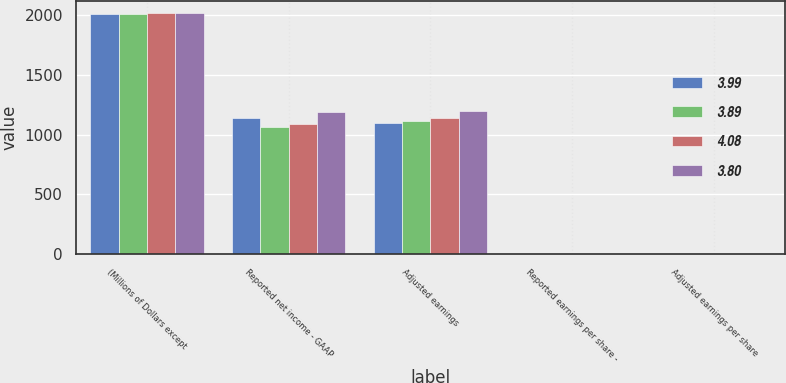Convert chart. <chart><loc_0><loc_0><loc_500><loc_500><stacked_bar_chart><ecel><fcel>(Millions of Dollars except<fcel>Reported net income - GAAP<fcel>Adjusted earnings<fcel>Reported earnings per share -<fcel>Adjusted earnings per share<nl><fcel>3.99<fcel>2012<fcel>1138<fcel>1098<fcel>3.88<fcel>3.75<nl><fcel>3.89<fcel>2013<fcel>1062<fcel>1112<fcel>3.62<fcel>3.8<nl><fcel>4.08<fcel>2014<fcel>1092<fcel>1140<fcel>3.73<fcel>3.89<nl><fcel>3.8<fcel>2015<fcel>1193<fcel>1196<fcel>4.07<fcel>4.08<nl></chart> 